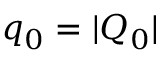<formula> <loc_0><loc_0><loc_500><loc_500>q _ { 0 } = | Q _ { 0 } |</formula> 